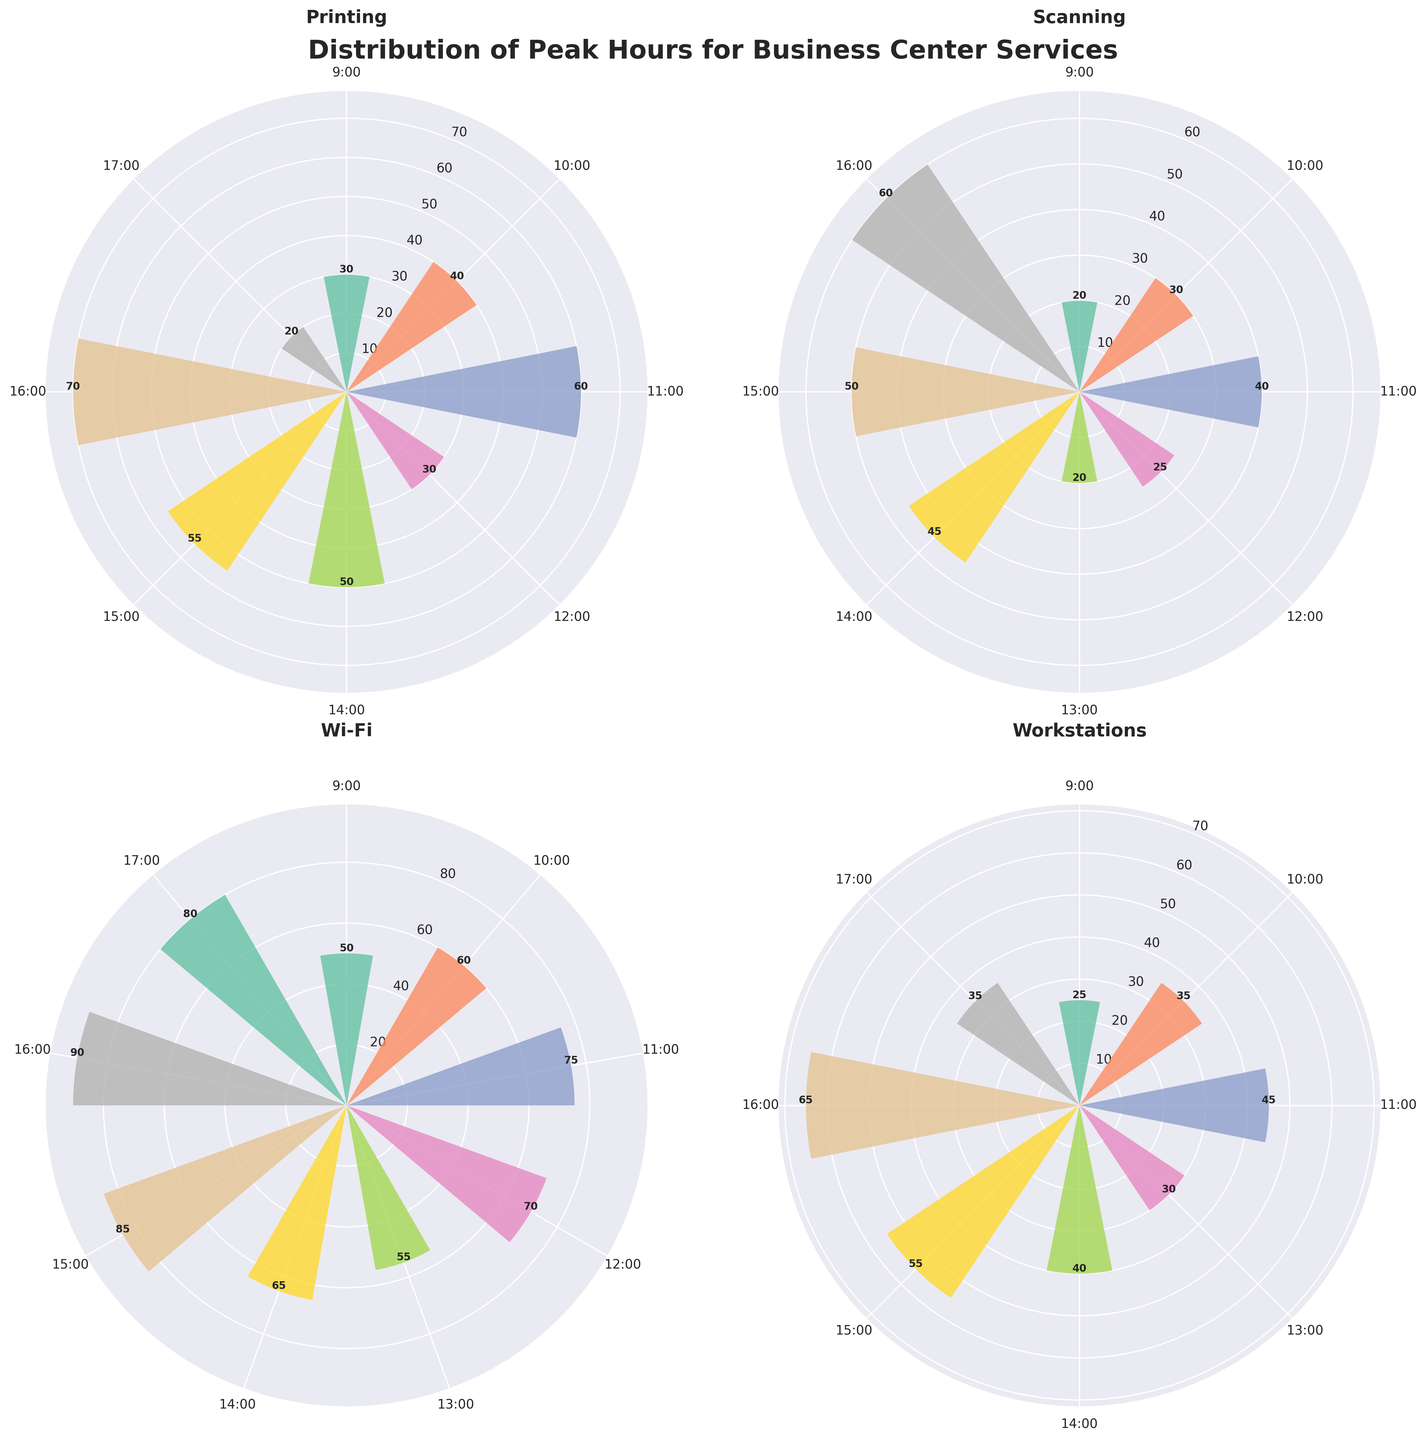What is the peak hour for Printing services? By examining the rose chart, the tallest bar under the Printing category represents the highest usage frequency. This peak occurs at 16:00.
Answer: 16:00 Which service has the highest usage frequency at 15:00? Looking at the 15:00 data points on each of the subplots, the tallest bar stands under the Wi-Fi category with a usage frequency of 85.
Answer: Wi-Fi What is the lowest usage frequency for Scanning services, and at what time does it occur? The smallest bar in the Scanning subplot corresponds to the 13:00 time, where the usage frequency is 20.
Answer: 20 at 13:00 Which service shows a consistent increase in usage frequency from 9:00 to 16:00? By comparing the trends in each rose chart, the Wi-Fi category shows a consistent increase in usage from 9:00 to 16:00.
Answer: Wi-Fi How many services peak at 16:00? By analyzing the highest bar in each subplot at 16:00, it is evident that Printing, Scanning, and Wi-Fi all have their peak at 16:00. Workstations do not.
Answer: 3 services Comparing Printing and Workstations, which one has a higher peak usage frequency, and what are their values? The peak for Printing is 70 at 16:00, and the peak for Workstations is 65 at 16:00. Therefore, Printing has a higher peak value.
Answer: Printing: 70, Workstations: 65 What is the average usage frequency for Wi-Fi between 9:00 and 16:00? The usage frequencies for Wi-Fi from 9:00 to 16:00 are 50, 60, 75, 70, 55, 65, 85, and 90. Summing these values results in 550, and the average is calculated as 550 / 8 = 68.75.
Answer: 68.75 Which service has the most evenly distributed usage throughout the day, and how can you tell? By looking at the variation in the heights of the bars, the Workstations category appears to have the most evenly distributed usage because the differences in bar heights are relatively small compared to other services.
Answer: Workstations At what time do Printing and Scanning services have the same usage frequency, and what is that frequency? By examining both subplots, Printing and Scanning both have a usage frequency of 30 at 10:00.
Answer: 10:00, 30 What is the difference in usage frequency between the peak hours for Wi-Fi and Scanning? The peak usage frequency for Wi-Fi is 90 at 16:00, and for Scanning, it is 60 at 16:00. The difference is 90 - 60 = 30.
Answer: 30 